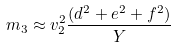<formula> <loc_0><loc_0><loc_500><loc_500>m _ { 3 } \approx v _ { 2 } ^ { 2 } \frac { ( d ^ { 2 } + e ^ { 2 } + f ^ { 2 } ) } { Y }</formula> 